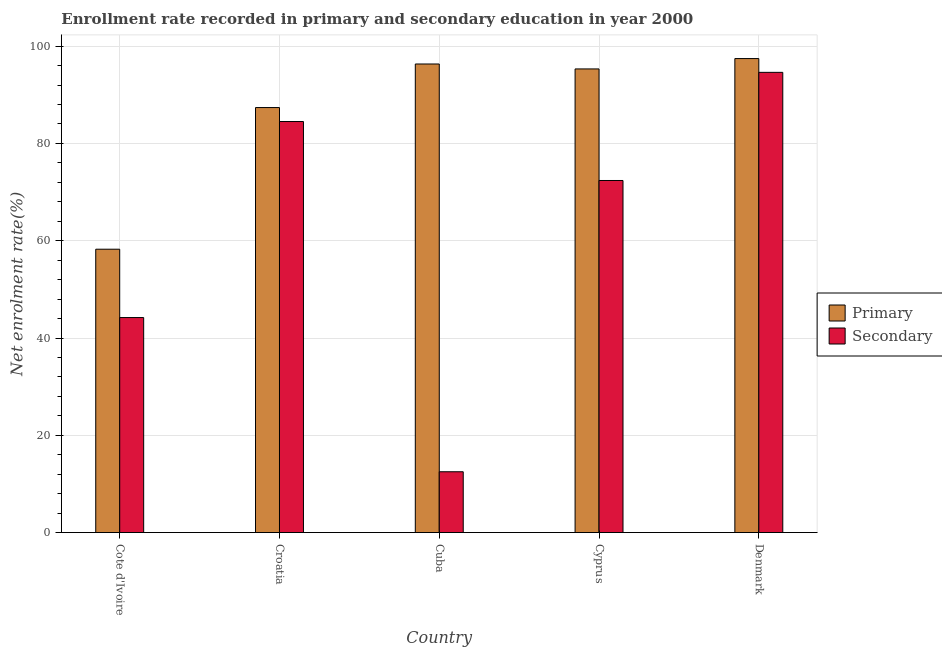What is the label of the 1st group of bars from the left?
Provide a succinct answer. Cote d'Ivoire. In how many cases, is the number of bars for a given country not equal to the number of legend labels?
Your answer should be compact. 0. What is the enrollment rate in secondary education in Croatia?
Your answer should be very brief. 84.51. Across all countries, what is the maximum enrollment rate in primary education?
Offer a very short reply. 97.45. Across all countries, what is the minimum enrollment rate in primary education?
Provide a succinct answer. 58.26. In which country was the enrollment rate in primary education minimum?
Your answer should be very brief. Cote d'Ivoire. What is the total enrollment rate in primary education in the graph?
Your answer should be very brief. 434.73. What is the difference between the enrollment rate in secondary education in Cote d'Ivoire and that in Denmark?
Give a very brief answer. -50.41. What is the difference between the enrollment rate in primary education in Denmark and the enrollment rate in secondary education in Cote d'Ivoire?
Your response must be concise. 53.24. What is the average enrollment rate in secondary education per country?
Offer a terse response. 61.64. What is the difference between the enrollment rate in secondary education and enrollment rate in primary education in Cote d'Ivoire?
Give a very brief answer. -14.05. What is the ratio of the enrollment rate in secondary education in Cote d'Ivoire to that in Cyprus?
Offer a terse response. 0.61. Is the difference between the enrollment rate in primary education in Cote d'Ivoire and Cyprus greater than the difference between the enrollment rate in secondary education in Cote d'Ivoire and Cyprus?
Make the answer very short. No. What is the difference between the highest and the second highest enrollment rate in secondary education?
Provide a short and direct response. 10.11. What is the difference between the highest and the lowest enrollment rate in primary education?
Offer a very short reply. 39.19. Is the sum of the enrollment rate in primary education in Cuba and Denmark greater than the maximum enrollment rate in secondary education across all countries?
Your response must be concise. Yes. What does the 1st bar from the left in Cote d'Ivoire represents?
Offer a terse response. Primary. What does the 1st bar from the right in Cyprus represents?
Provide a succinct answer. Secondary. Are all the bars in the graph horizontal?
Your answer should be very brief. No. What is the difference between two consecutive major ticks on the Y-axis?
Offer a terse response. 20. Are the values on the major ticks of Y-axis written in scientific E-notation?
Give a very brief answer. No. Where does the legend appear in the graph?
Your response must be concise. Center right. How many legend labels are there?
Your response must be concise. 2. How are the legend labels stacked?
Offer a terse response. Vertical. What is the title of the graph?
Ensure brevity in your answer.  Enrollment rate recorded in primary and secondary education in year 2000. What is the label or title of the X-axis?
Provide a succinct answer. Country. What is the label or title of the Y-axis?
Your answer should be very brief. Net enrolment rate(%). What is the Net enrolment rate(%) in Primary in Cote d'Ivoire?
Offer a very short reply. 58.26. What is the Net enrolment rate(%) in Secondary in Cote d'Ivoire?
Offer a terse response. 44.21. What is the Net enrolment rate(%) of Primary in Croatia?
Your response must be concise. 87.38. What is the Net enrolment rate(%) in Secondary in Croatia?
Your response must be concise. 84.51. What is the Net enrolment rate(%) in Primary in Cuba?
Ensure brevity in your answer.  96.33. What is the Net enrolment rate(%) in Secondary in Cuba?
Offer a terse response. 12.51. What is the Net enrolment rate(%) of Primary in Cyprus?
Your answer should be very brief. 95.32. What is the Net enrolment rate(%) in Secondary in Cyprus?
Offer a terse response. 72.39. What is the Net enrolment rate(%) of Primary in Denmark?
Keep it short and to the point. 97.45. What is the Net enrolment rate(%) of Secondary in Denmark?
Provide a succinct answer. 94.61. Across all countries, what is the maximum Net enrolment rate(%) of Primary?
Offer a terse response. 97.45. Across all countries, what is the maximum Net enrolment rate(%) of Secondary?
Your answer should be compact. 94.61. Across all countries, what is the minimum Net enrolment rate(%) in Primary?
Your response must be concise. 58.26. Across all countries, what is the minimum Net enrolment rate(%) in Secondary?
Make the answer very short. 12.51. What is the total Net enrolment rate(%) of Primary in the graph?
Your response must be concise. 434.73. What is the total Net enrolment rate(%) in Secondary in the graph?
Your answer should be very brief. 308.22. What is the difference between the Net enrolment rate(%) of Primary in Cote d'Ivoire and that in Croatia?
Your answer should be very brief. -29.12. What is the difference between the Net enrolment rate(%) of Secondary in Cote d'Ivoire and that in Croatia?
Your answer should be very brief. -40.3. What is the difference between the Net enrolment rate(%) in Primary in Cote d'Ivoire and that in Cuba?
Your answer should be compact. -38.08. What is the difference between the Net enrolment rate(%) of Secondary in Cote d'Ivoire and that in Cuba?
Your response must be concise. 31.7. What is the difference between the Net enrolment rate(%) of Primary in Cote d'Ivoire and that in Cyprus?
Offer a terse response. -37.06. What is the difference between the Net enrolment rate(%) in Secondary in Cote d'Ivoire and that in Cyprus?
Provide a short and direct response. -28.18. What is the difference between the Net enrolment rate(%) in Primary in Cote d'Ivoire and that in Denmark?
Offer a very short reply. -39.19. What is the difference between the Net enrolment rate(%) in Secondary in Cote d'Ivoire and that in Denmark?
Provide a succinct answer. -50.41. What is the difference between the Net enrolment rate(%) in Primary in Croatia and that in Cuba?
Keep it short and to the point. -8.96. What is the difference between the Net enrolment rate(%) of Secondary in Croatia and that in Cuba?
Ensure brevity in your answer.  72. What is the difference between the Net enrolment rate(%) in Primary in Croatia and that in Cyprus?
Your answer should be compact. -7.94. What is the difference between the Net enrolment rate(%) in Secondary in Croatia and that in Cyprus?
Your answer should be compact. 12.12. What is the difference between the Net enrolment rate(%) of Primary in Croatia and that in Denmark?
Provide a short and direct response. -10.07. What is the difference between the Net enrolment rate(%) in Secondary in Croatia and that in Denmark?
Offer a very short reply. -10.11. What is the difference between the Net enrolment rate(%) in Primary in Cuba and that in Cyprus?
Keep it short and to the point. 1.01. What is the difference between the Net enrolment rate(%) of Secondary in Cuba and that in Cyprus?
Offer a terse response. -59.88. What is the difference between the Net enrolment rate(%) in Primary in Cuba and that in Denmark?
Your response must be concise. -1.11. What is the difference between the Net enrolment rate(%) in Secondary in Cuba and that in Denmark?
Offer a very short reply. -82.11. What is the difference between the Net enrolment rate(%) of Primary in Cyprus and that in Denmark?
Provide a short and direct response. -2.13. What is the difference between the Net enrolment rate(%) of Secondary in Cyprus and that in Denmark?
Your answer should be very brief. -22.23. What is the difference between the Net enrolment rate(%) in Primary in Cote d'Ivoire and the Net enrolment rate(%) in Secondary in Croatia?
Your response must be concise. -26.25. What is the difference between the Net enrolment rate(%) in Primary in Cote d'Ivoire and the Net enrolment rate(%) in Secondary in Cuba?
Give a very brief answer. 45.75. What is the difference between the Net enrolment rate(%) of Primary in Cote d'Ivoire and the Net enrolment rate(%) of Secondary in Cyprus?
Provide a succinct answer. -14.13. What is the difference between the Net enrolment rate(%) of Primary in Cote d'Ivoire and the Net enrolment rate(%) of Secondary in Denmark?
Your answer should be compact. -36.36. What is the difference between the Net enrolment rate(%) of Primary in Croatia and the Net enrolment rate(%) of Secondary in Cuba?
Provide a succinct answer. 74.87. What is the difference between the Net enrolment rate(%) of Primary in Croatia and the Net enrolment rate(%) of Secondary in Cyprus?
Give a very brief answer. 14.99. What is the difference between the Net enrolment rate(%) in Primary in Croatia and the Net enrolment rate(%) in Secondary in Denmark?
Provide a short and direct response. -7.24. What is the difference between the Net enrolment rate(%) of Primary in Cuba and the Net enrolment rate(%) of Secondary in Cyprus?
Your answer should be compact. 23.95. What is the difference between the Net enrolment rate(%) of Primary in Cuba and the Net enrolment rate(%) of Secondary in Denmark?
Offer a very short reply. 1.72. What is the difference between the Net enrolment rate(%) in Primary in Cyprus and the Net enrolment rate(%) in Secondary in Denmark?
Your response must be concise. 0.7. What is the average Net enrolment rate(%) in Primary per country?
Make the answer very short. 86.95. What is the average Net enrolment rate(%) in Secondary per country?
Provide a short and direct response. 61.64. What is the difference between the Net enrolment rate(%) in Primary and Net enrolment rate(%) in Secondary in Cote d'Ivoire?
Ensure brevity in your answer.  14.05. What is the difference between the Net enrolment rate(%) in Primary and Net enrolment rate(%) in Secondary in Croatia?
Your response must be concise. 2.87. What is the difference between the Net enrolment rate(%) of Primary and Net enrolment rate(%) of Secondary in Cuba?
Keep it short and to the point. 83.83. What is the difference between the Net enrolment rate(%) of Primary and Net enrolment rate(%) of Secondary in Cyprus?
Keep it short and to the point. 22.93. What is the difference between the Net enrolment rate(%) in Primary and Net enrolment rate(%) in Secondary in Denmark?
Offer a terse response. 2.83. What is the ratio of the Net enrolment rate(%) of Primary in Cote d'Ivoire to that in Croatia?
Offer a very short reply. 0.67. What is the ratio of the Net enrolment rate(%) in Secondary in Cote d'Ivoire to that in Croatia?
Make the answer very short. 0.52. What is the ratio of the Net enrolment rate(%) in Primary in Cote d'Ivoire to that in Cuba?
Provide a short and direct response. 0.6. What is the ratio of the Net enrolment rate(%) in Secondary in Cote d'Ivoire to that in Cuba?
Make the answer very short. 3.53. What is the ratio of the Net enrolment rate(%) in Primary in Cote d'Ivoire to that in Cyprus?
Make the answer very short. 0.61. What is the ratio of the Net enrolment rate(%) in Secondary in Cote d'Ivoire to that in Cyprus?
Ensure brevity in your answer.  0.61. What is the ratio of the Net enrolment rate(%) of Primary in Cote d'Ivoire to that in Denmark?
Your answer should be compact. 0.6. What is the ratio of the Net enrolment rate(%) in Secondary in Cote d'Ivoire to that in Denmark?
Give a very brief answer. 0.47. What is the ratio of the Net enrolment rate(%) in Primary in Croatia to that in Cuba?
Offer a very short reply. 0.91. What is the ratio of the Net enrolment rate(%) of Secondary in Croatia to that in Cuba?
Provide a short and direct response. 6.76. What is the ratio of the Net enrolment rate(%) of Primary in Croatia to that in Cyprus?
Give a very brief answer. 0.92. What is the ratio of the Net enrolment rate(%) of Secondary in Croatia to that in Cyprus?
Ensure brevity in your answer.  1.17. What is the ratio of the Net enrolment rate(%) of Primary in Croatia to that in Denmark?
Provide a short and direct response. 0.9. What is the ratio of the Net enrolment rate(%) of Secondary in Croatia to that in Denmark?
Provide a succinct answer. 0.89. What is the ratio of the Net enrolment rate(%) of Primary in Cuba to that in Cyprus?
Ensure brevity in your answer.  1.01. What is the ratio of the Net enrolment rate(%) in Secondary in Cuba to that in Cyprus?
Make the answer very short. 0.17. What is the ratio of the Net enrolment rate(%) in Primary in Cuba to that in Denmark?
Keep it short and to the point. 0.99. What is the ratio of the Net enrolment rate(%) in Secondary in Cuba to that in Denmark?
Your answer should be very brief. 0.13. What is the ratio of the Net enrolment rate(%) of Primary in Cyprus to that in Denmark?
Offer a very short reply. 0.98. What is the ratio of the Net enrolment rate(%) of Secondary in Cyprus to that in Denmark?
Give a very brief answer. 0.77. What is the difference between the highest and the second highest Net enrolment rate(%) of Primary?
Your answer should be very brief. 1.11. What is the difference between the highest and the second highest Net enrolment rate(%) of Secondary?
Your answer should be very brief. 10.11. What is the difference between the highest and the lowest Net enrolment rate(%) of Primary?
Make the answer very short. 39.19. What is the difference between the highest and the lowest Net enrolment rate(%) in Secondary?
Give a very brief answer. 82.11. 